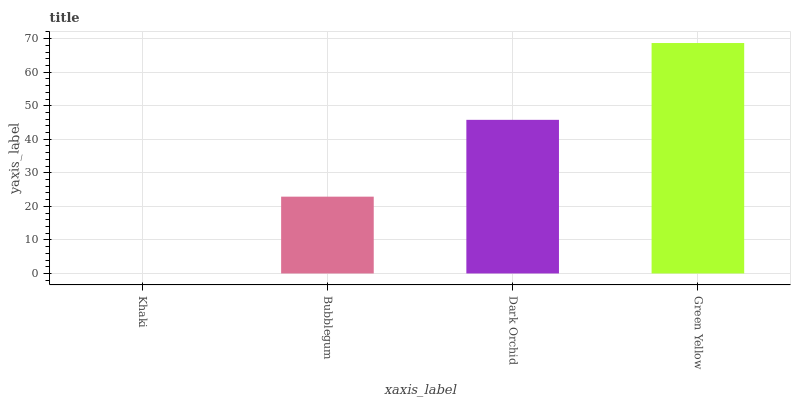Is Bubblegum the minimum?
Answer yes or no. No. Is Bubblegum the maximum?
Answer yes or no. No. Is Bubblegum greater than Khaki?
Answer yes or no. Yes. Is Khaki less than Bubblegum?
Answer yes or no. Yes. Is Khaki greater than Bubblegum?
Answer yes or no. No. Is Bubblegum less than Khaki?
Answer yes or no. No. Is Dark Orchid the high median?
Answer yes or no. Yes. Is Bubblegum the low median?
Answer yes or no. Yes. Is Green Yellow the high median?
Answer yes or no. No. Is Khaki the low median?
Answer yes or no. No. 